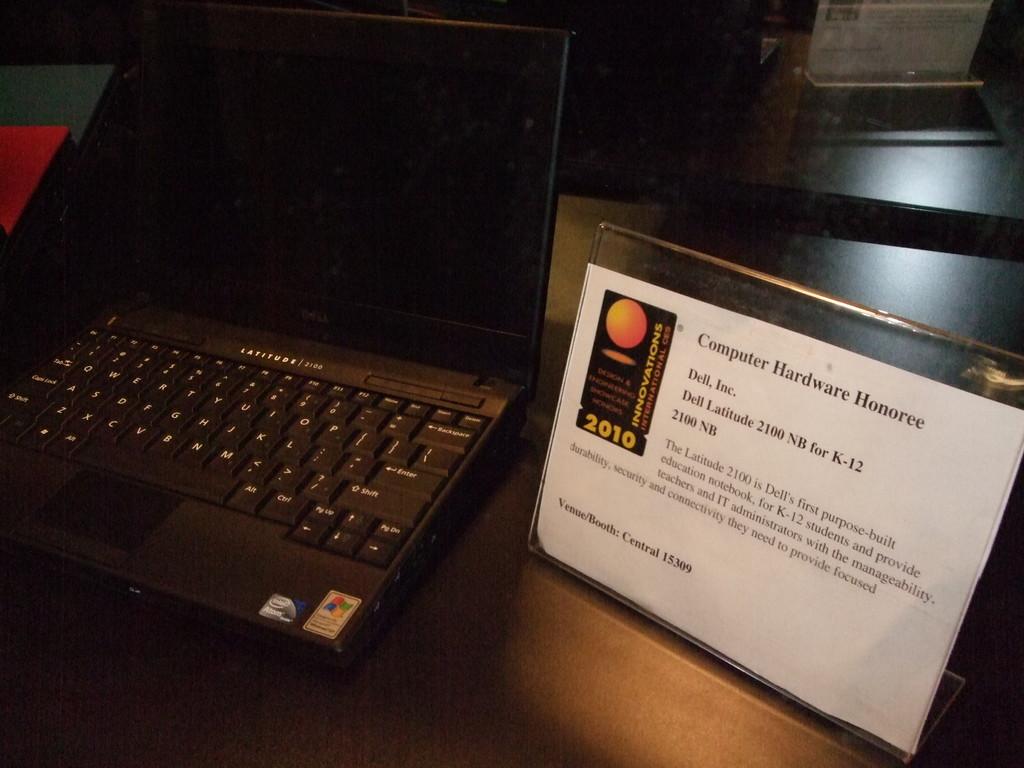What does the top of that paper say?
Give a very brief answer. Computer hardware honoree. What is the brand of the computer?
Your answer should be compact. Dell. 